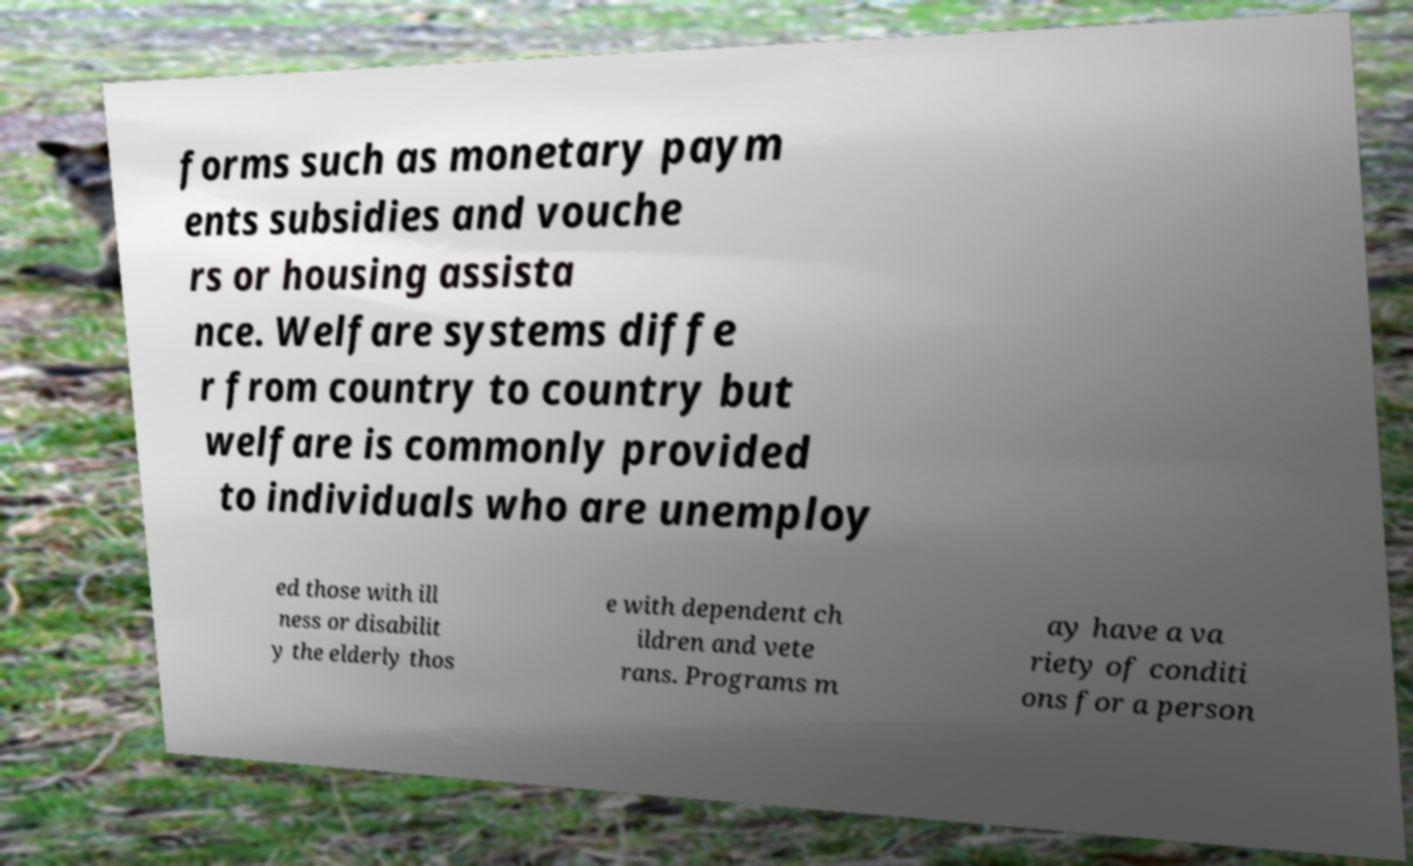Can you accurately transcribe the text from the provided image for me? forms such as monetary paym ents subsidies and vouche rs or housing assista nce. Welfare systems diffe r from country to country but welfare is commonly provided to individuals who are unemploy ed those with ill ness or disabilit y the elderly thos e with dependent ch ildren and vete rans. Programs m ay have a va riety of conditi ons for a person 